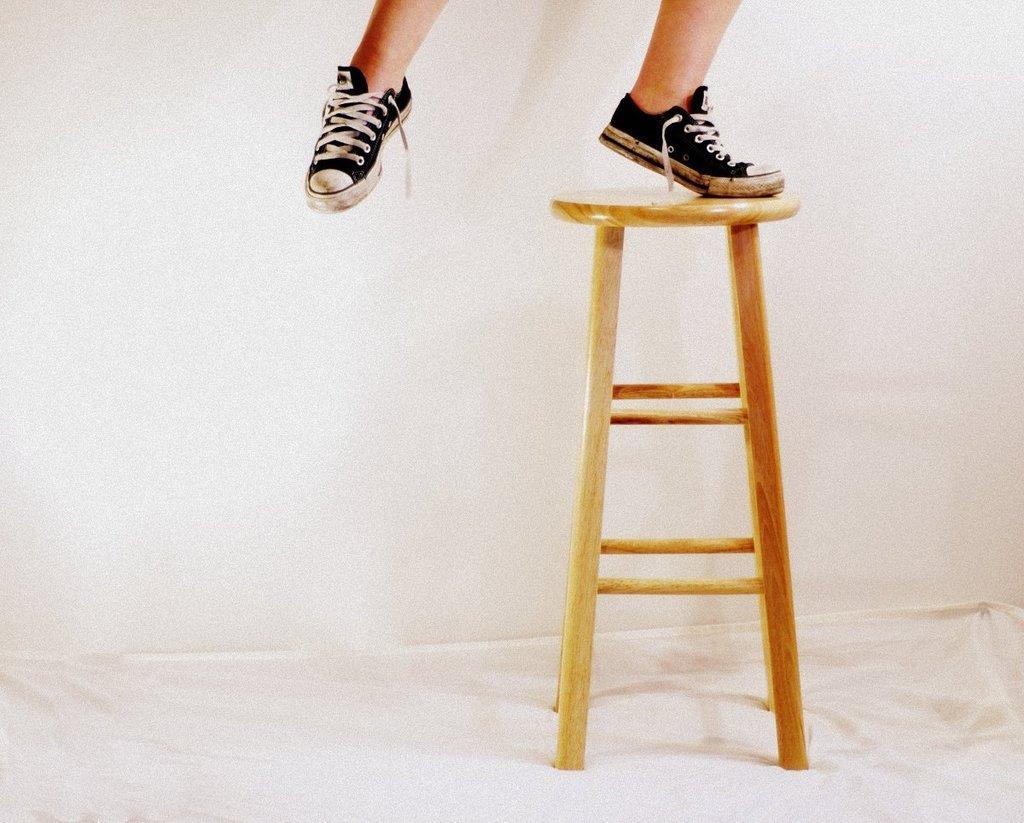Can you describe this image briefly? In this picture we can see a person is standing on the stool, and the person wore shoes. 